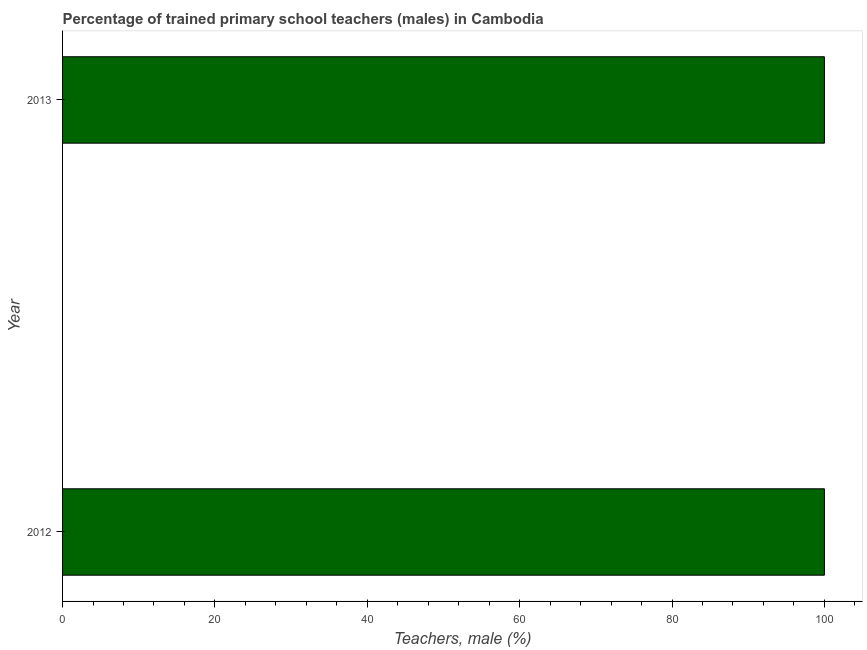Does the graph contain grids?
Offer a terse response. No. What is the title of the graph?
Your answer should be very brief. Percentage of trained primary school teachers (males) in Cambodia. What is the label or title of the X-axis?
Provide a short and direct response. Teachers, male (%). In which year was the percentage of trained male teachers maximum?
Offer a very short reply. 2012. In which year was the percentage of trained male teachers minimum?
Make the answer very short. 2012. What is the sum of the percentage of trained male teachers?
Make the answer very short. 200. What is the difference between the percentage of trained male teachers in 2012 and 2013?
Ensure brevity in your answer.  0. What is the median percentage of trained male teachers?
Your answer should be very brief. 100. In how many years, is the percentage of trained male teachers greater than 88 %?
Offer a terse response. 2. Is the percentage of trained male teachers in 2012 less than that in 2013?
Ensure brevity in your answer.  No. Are all the bars in the graph horizontal?
Your response must be concise. Yes. How many years are there in the graph?
Give a very brief answer. 2. What is the Teachers, male (%) in 2012?
Offer a terse response. 100. 